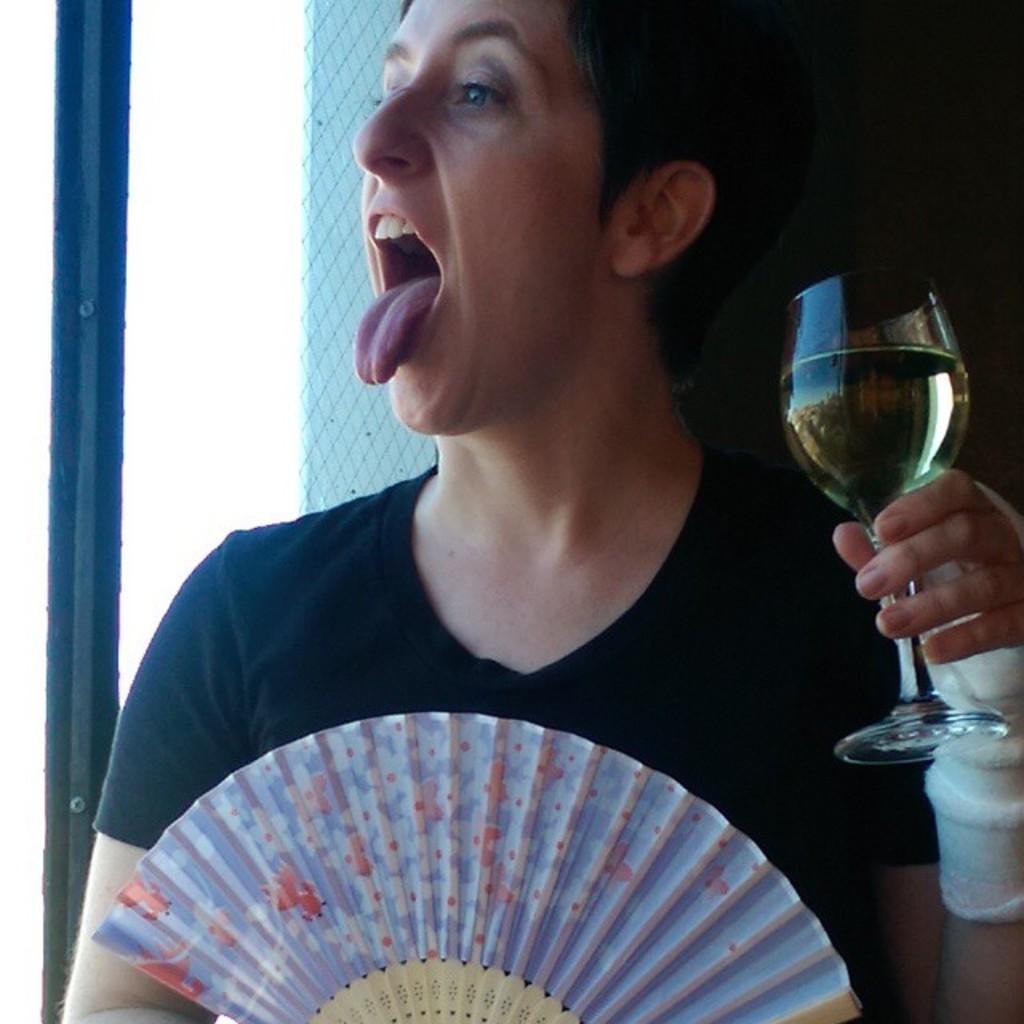Could you give a brief overview of what you see in this image? The man in the black T-shirt is holding a hand fan in one of his hands. In the other hand, he is holding the glass containing the liquid. Behind him, we see a white wall. On the left side, we see the pole. 